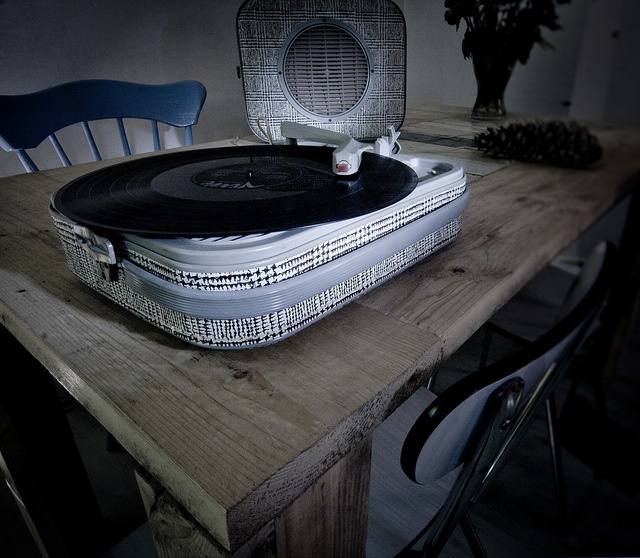Describe the objects in this image and their specific colors. I can see dining table in black, gray, and darkgray tones, suitcase in black, darkgray, gray, and lavender tones, chair in black and gray tones, chair in black, navy, gray, and blue tones, and vase in black and gray tones in this image. 